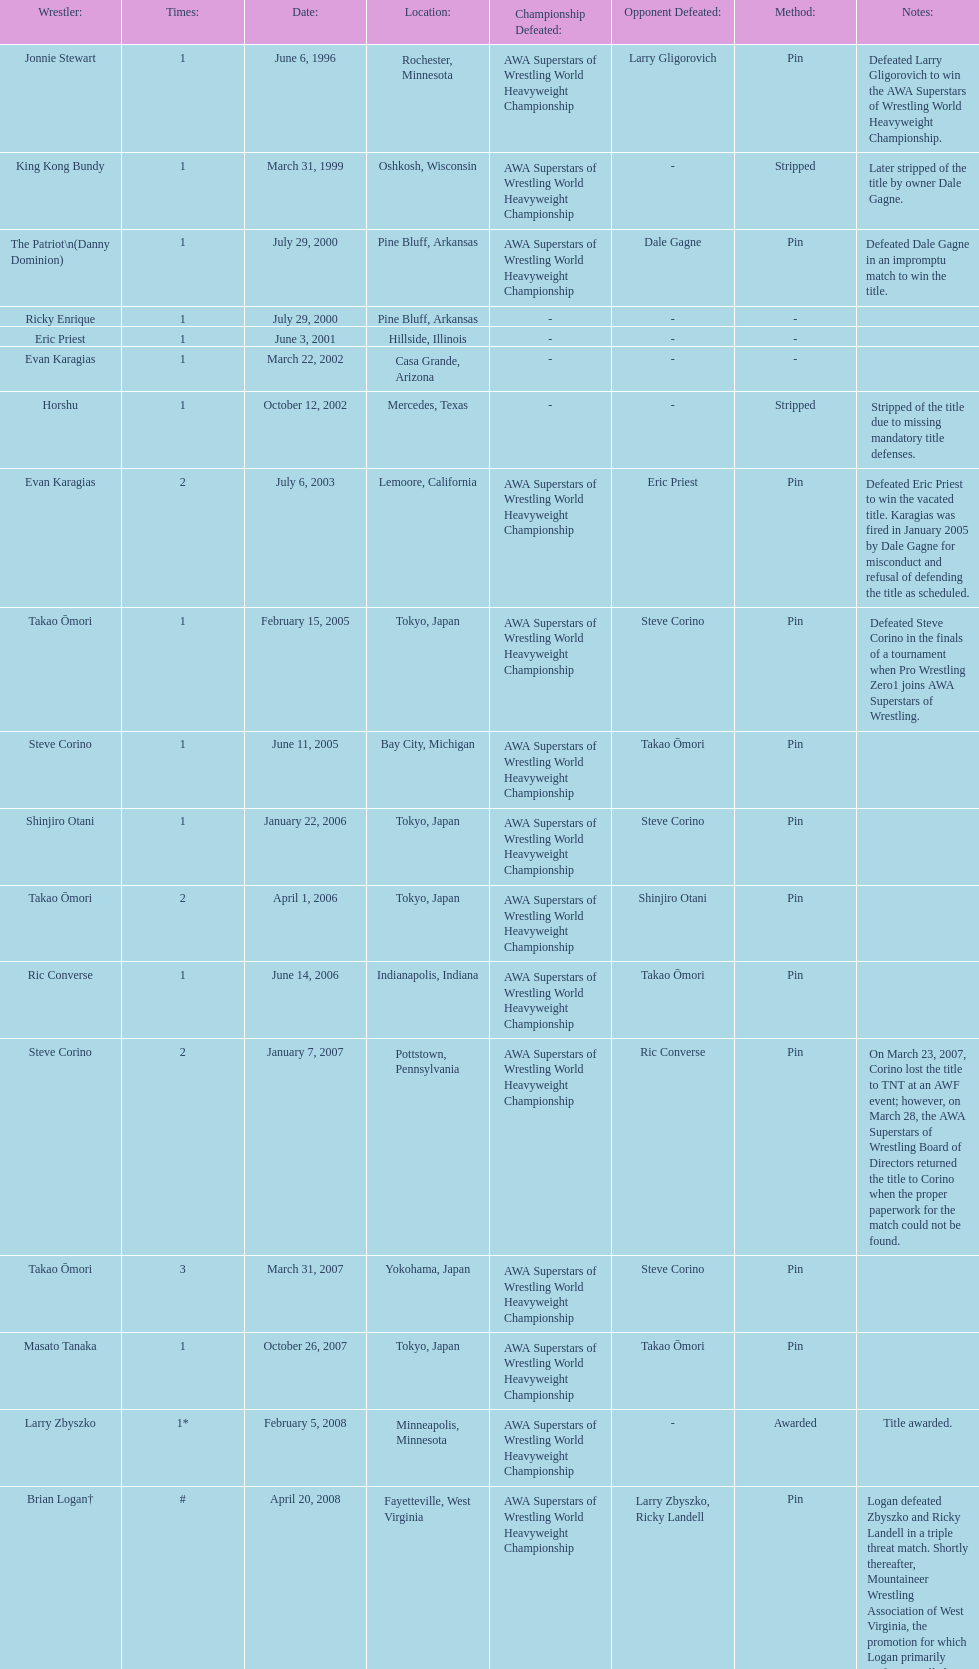What are the number of matches that happened in japan? 5. 